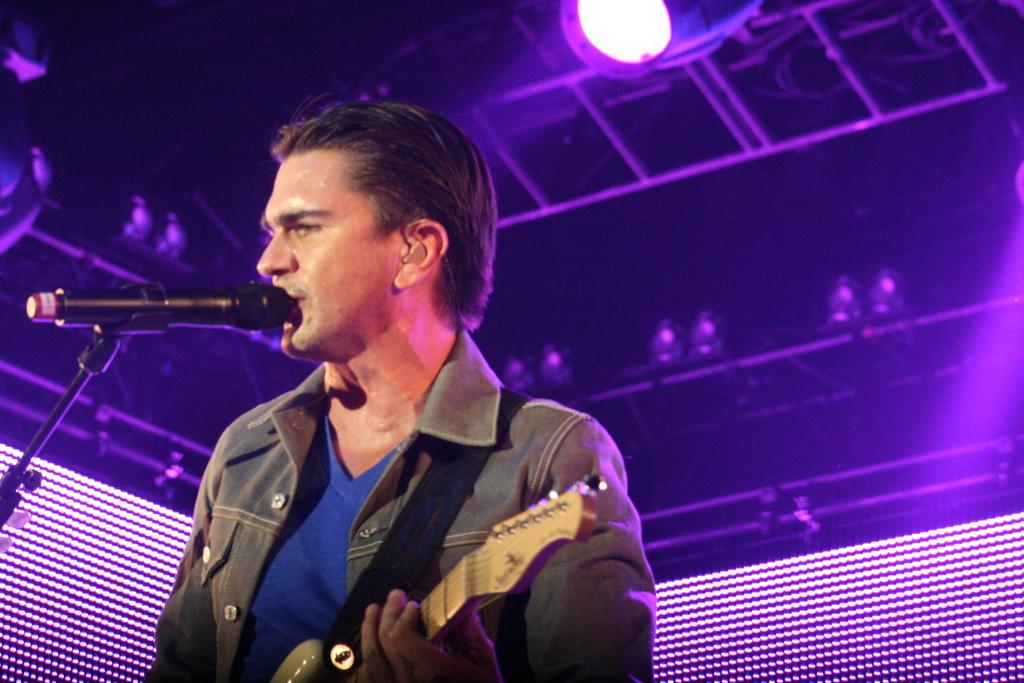What is the man in the image doing? The man is singing and playing a guitar in the image. How is the man amplifying his voice in the image? The man is using a microphone in the image. What can be seen in the background of the image? There is a light and metal rods in the background of the image. Where are the dolls resting in the image? There are no dolls present in the image. What type of trail can be seen in the background of the image? There is no trail visible in the background of the image. 